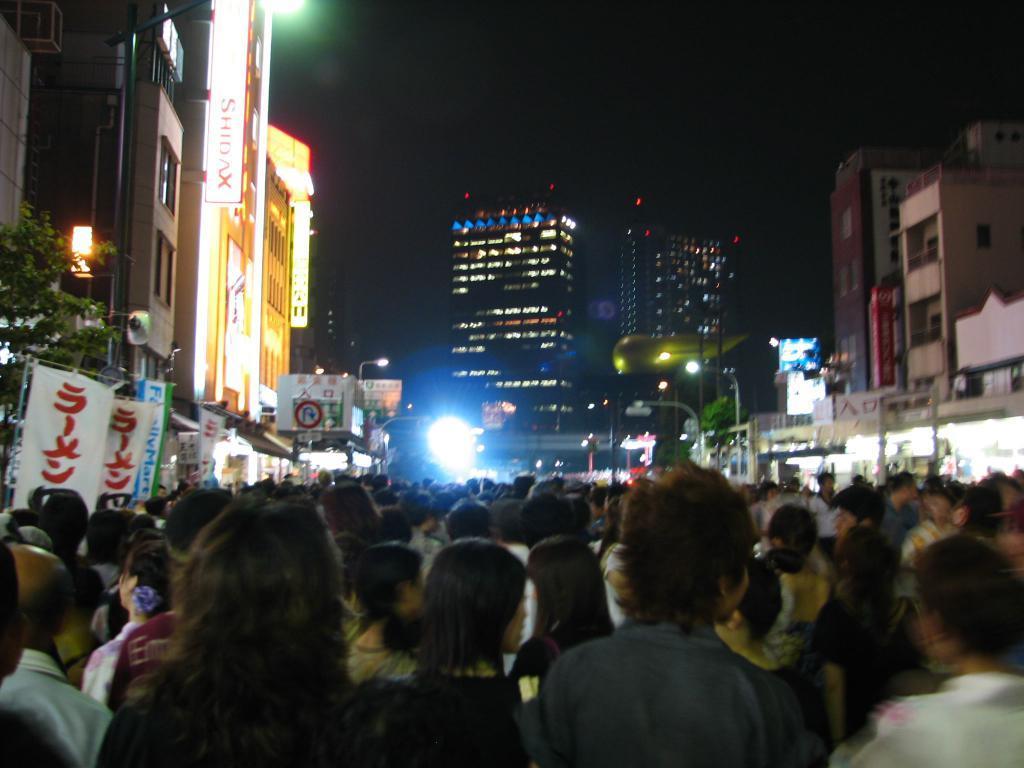Please provide a concise description of this image. In the foreground I can see a crowd on the road, boards, trees, poles and lights. In the background I can see buildings and the sky. This image is taken may be during night on the road. 